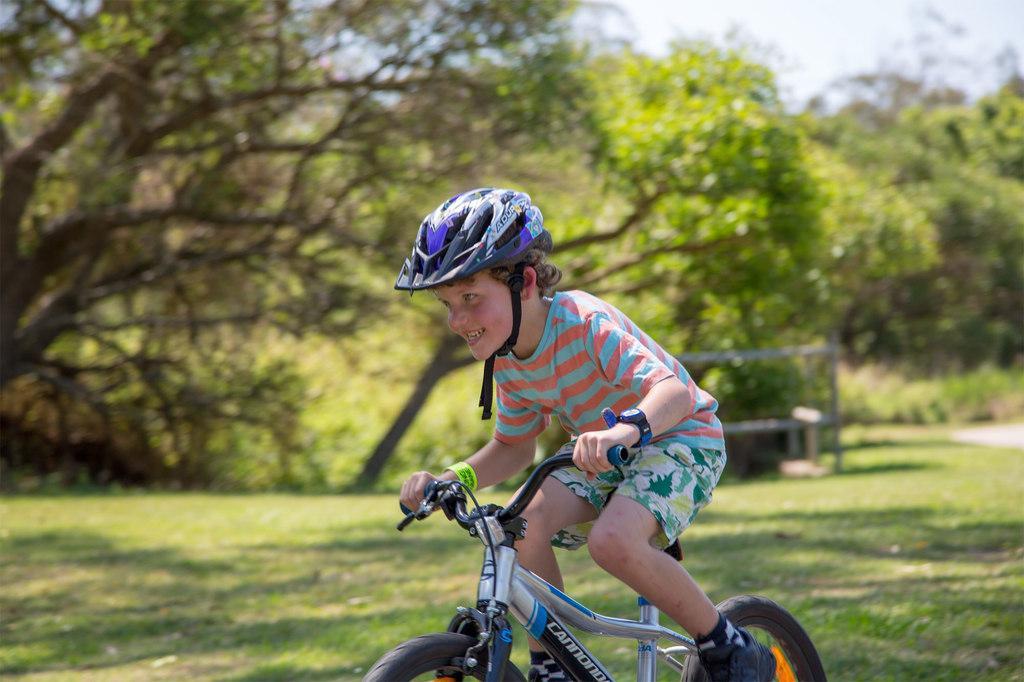Please provide a concise description of this image. In this picture there is a boy riding a bicycle. There is some grass on the ground, bench and some trees are seen in the background. 